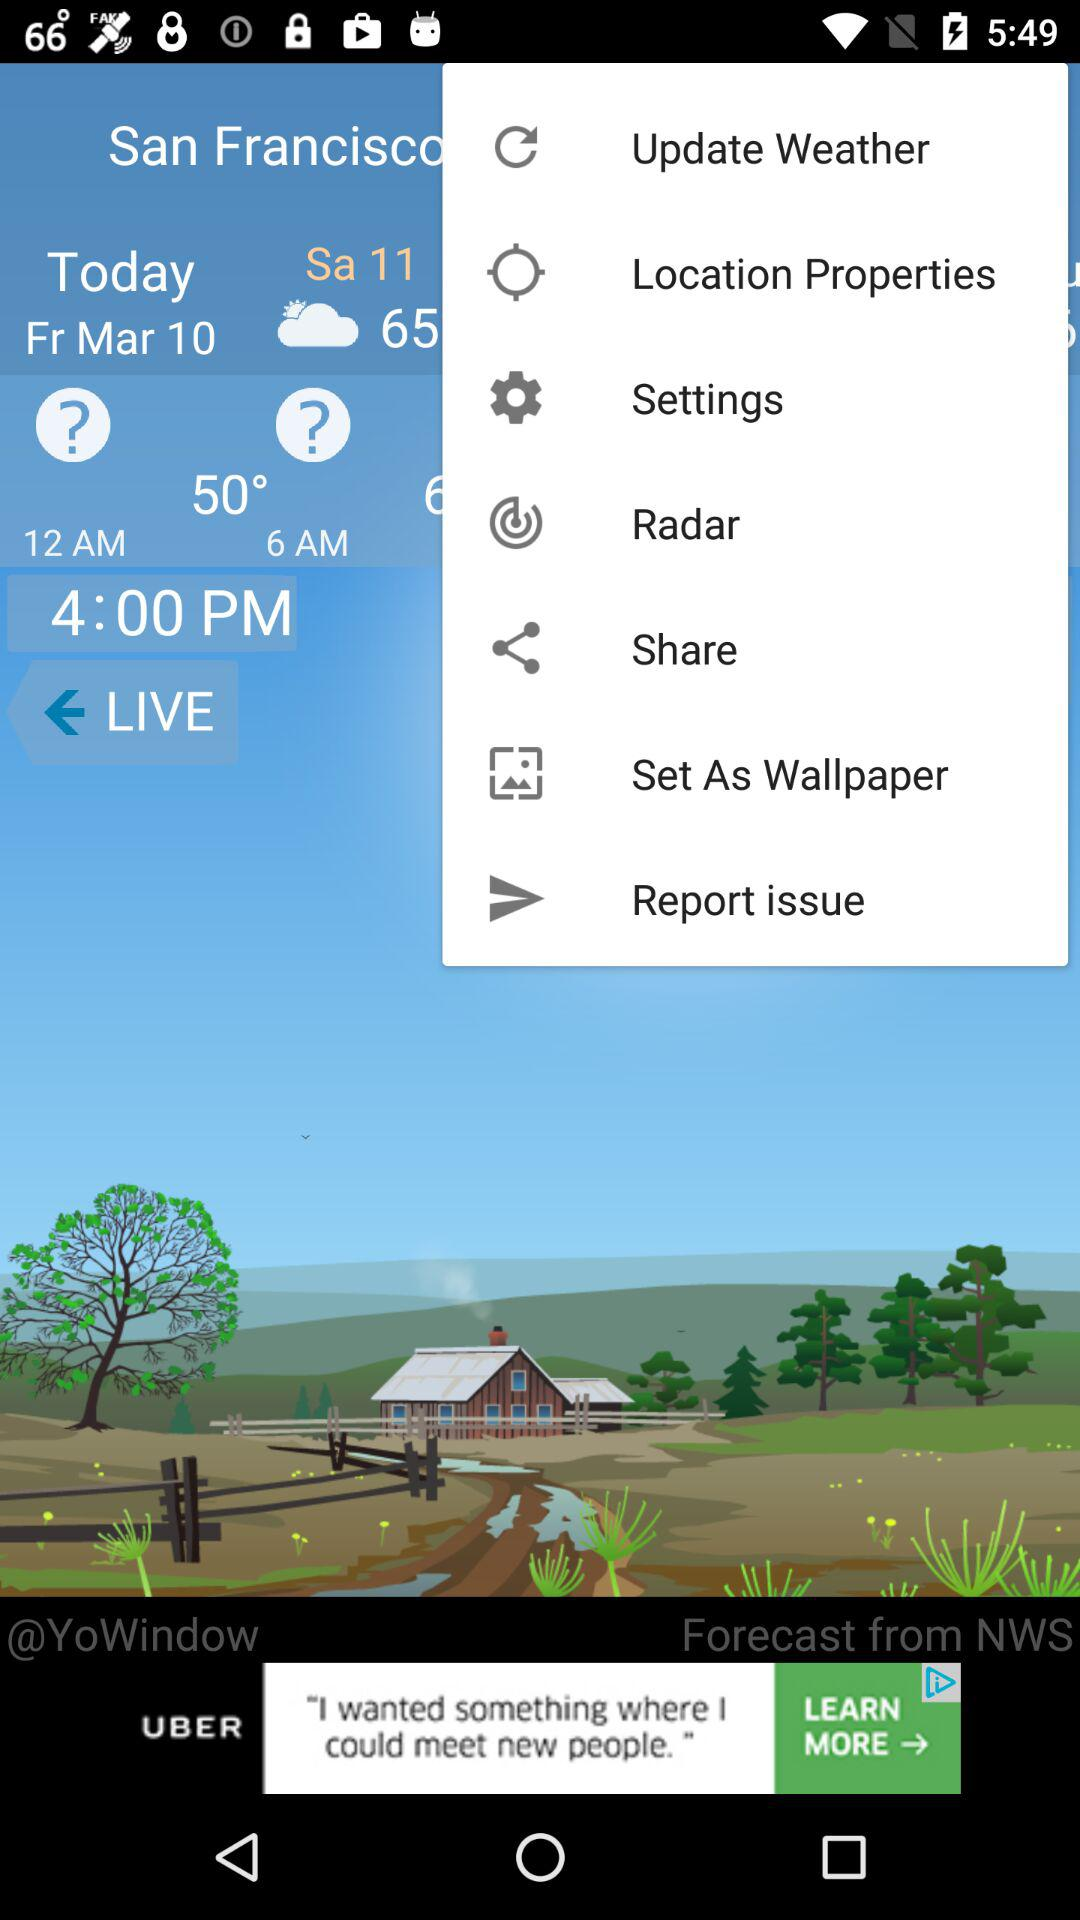What is today's date? Today's date is Friday, March 10. 